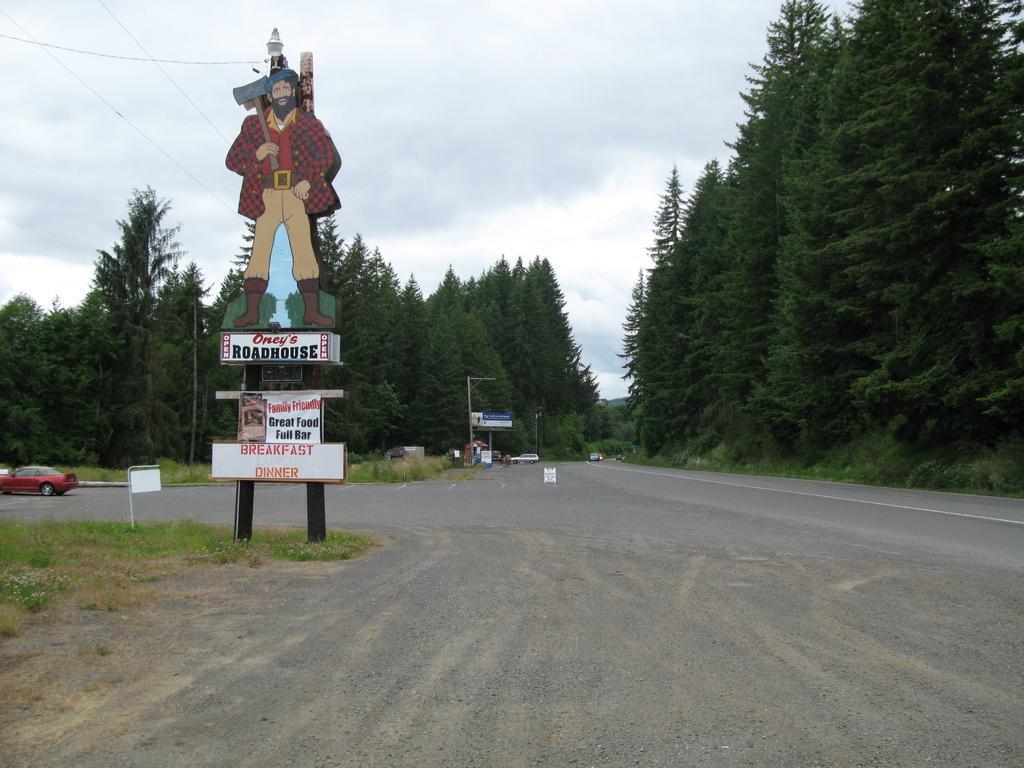In one or two sentences, can you explain what this image depicts? In this image we can see trees, there are vehicles, there are some boards with text on them, there is a board with looks like a person, also we can see the sky. 